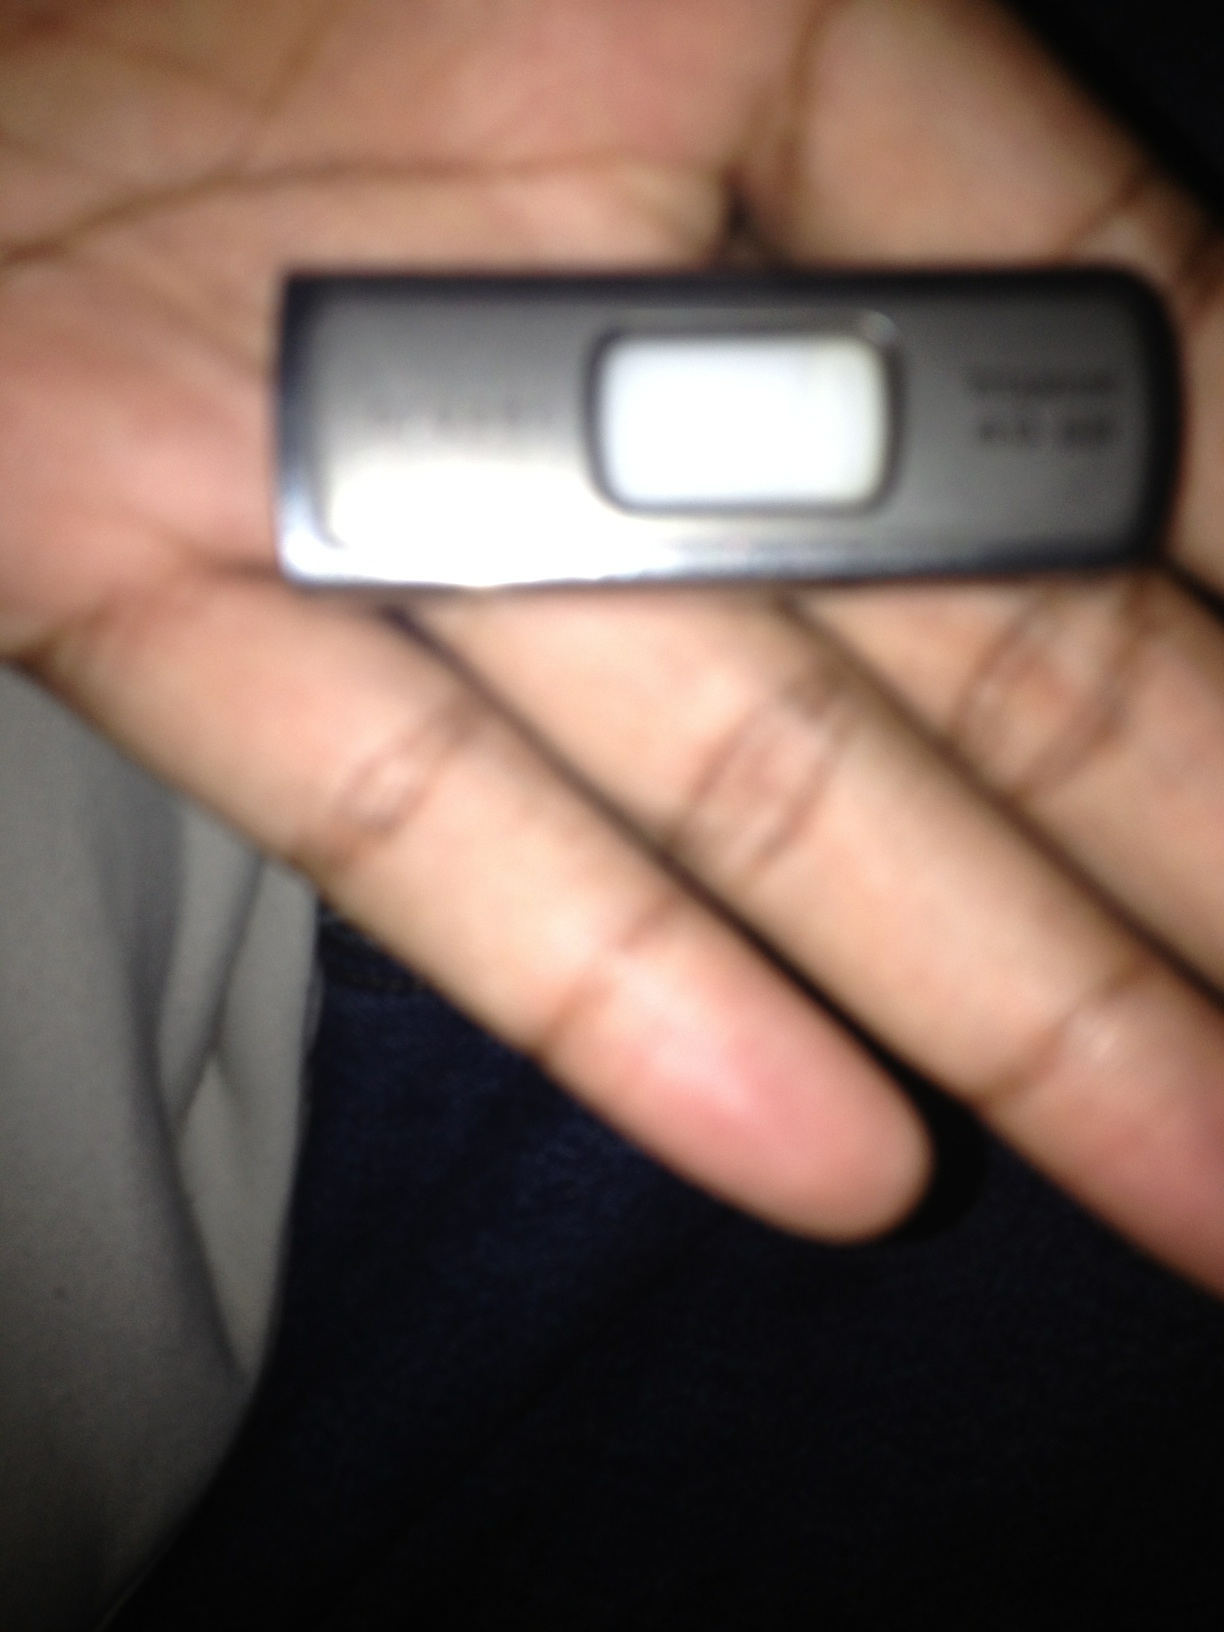Could you describe a casual, everyday use for this flash drive? An everyday use for this flash drive could be a student storing their school assignments and projects. They could save their essays, presentations, and research papers on the drive to easily access and continue their work on different computers, whether at home, in the school library, or at a friend's house. 